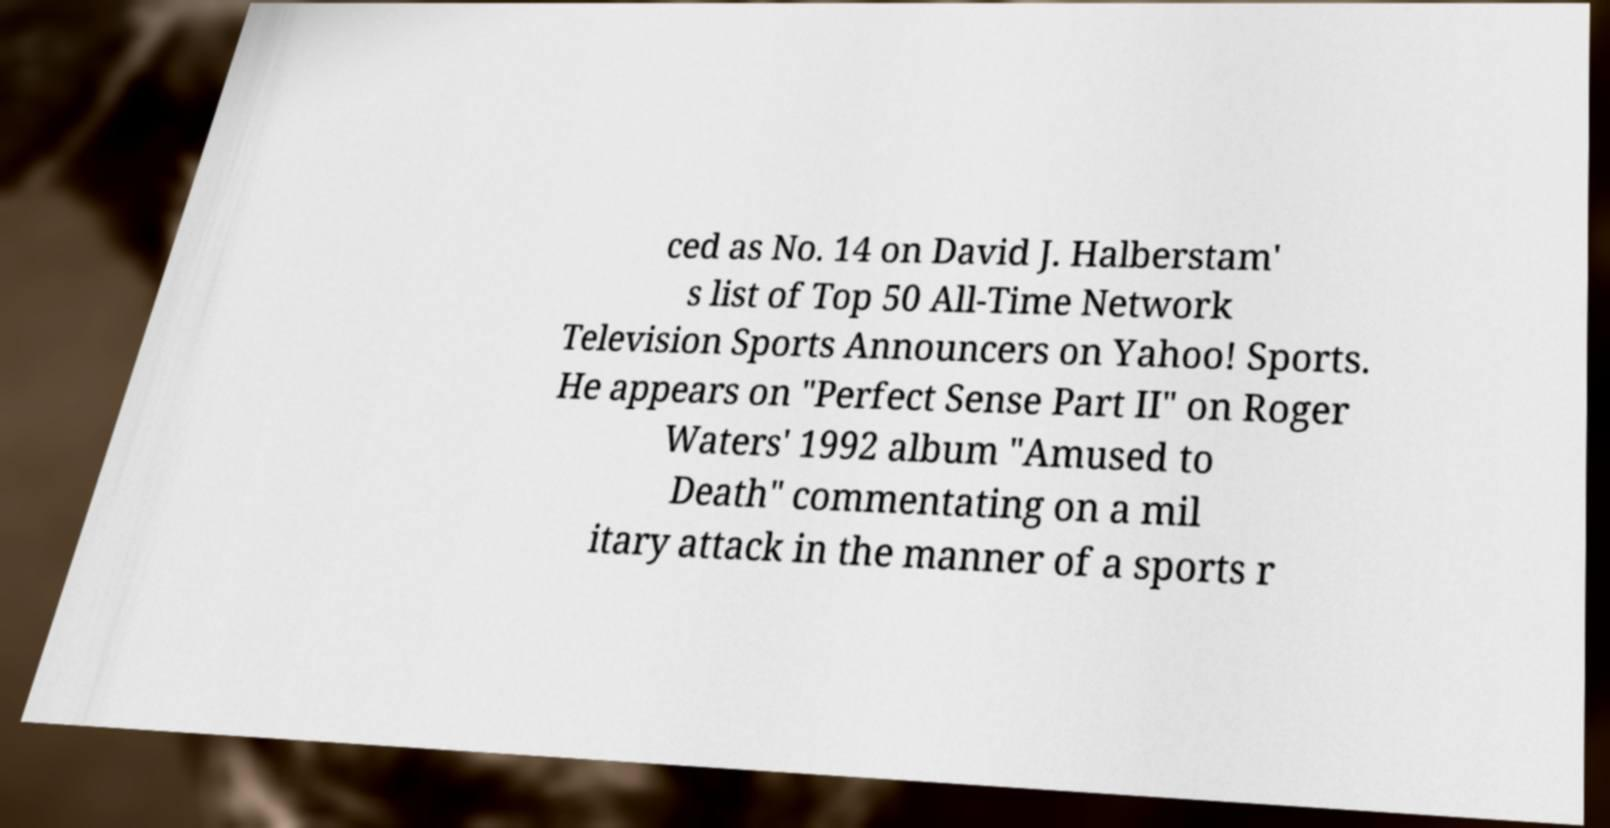Can you accurately transcribe the text from the provided image for me? ced as No. 14 on David J. Halberstam' s list of Top 50 All-Time Network Television Sports Announcers on Yahoo! Sports. He appears on "Perfect Sense Part II" on Roger Waters' 1992 album "Amused to Death" commentating on a mil itary attack in the manner of a sports r 